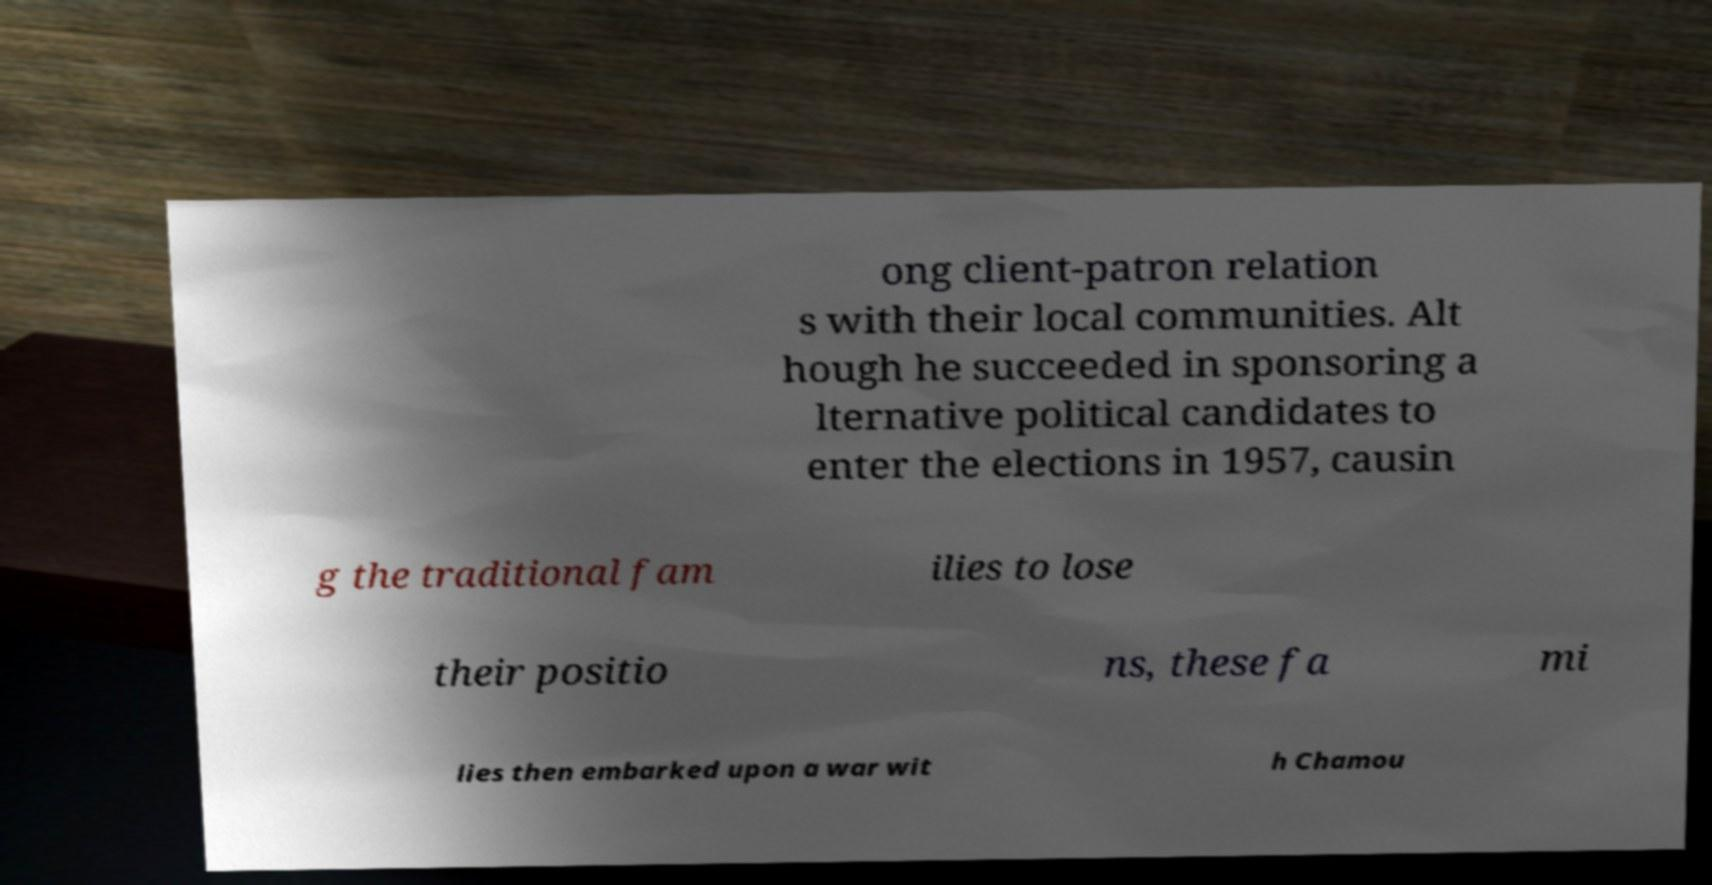I need the written content from this picture converted into text. Can you do that? ong client-patron relation s with their local communities. Alt hough he succeeded in sponsoring a lternative political candidates to enter the elections in 1957, causin g the traditional fam ilies to lose their positio ns, these fa mi lies then embarked upon a war wit h Chamou 